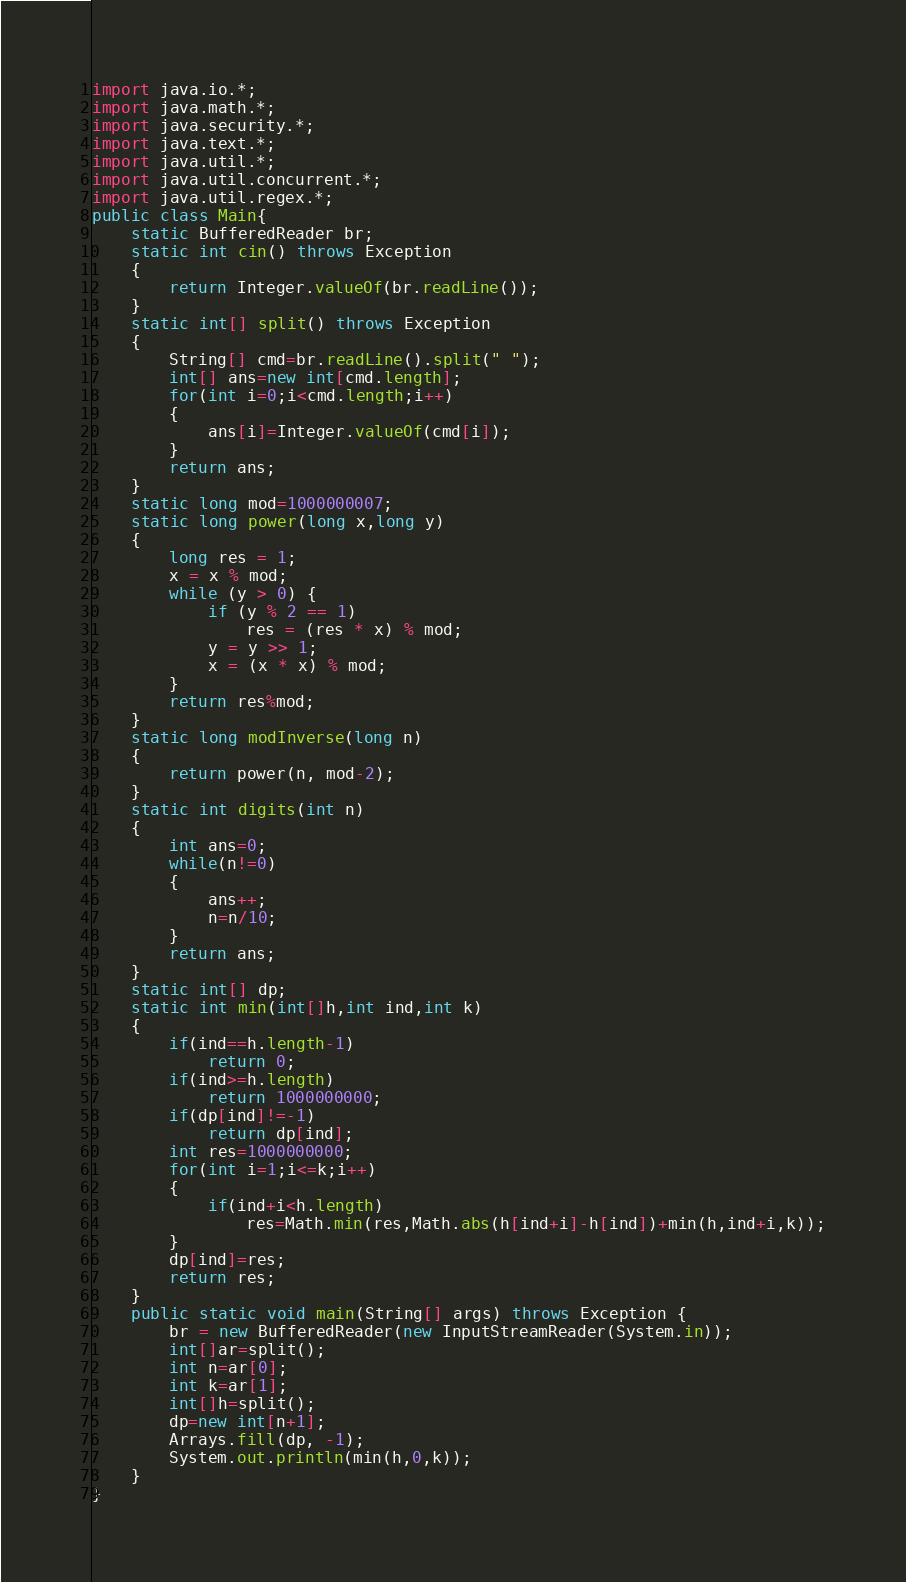Convert code to text. <code><loc_0><loc_0><loc_500><loc_500><_Java_>
import java.io.*;
import java.math.*;
import java.security.*;
import java.text.*;
import java.util.*;
import java.util.concurrent.*;
import java.util.regex.*;
public class Main{
	static BufferedReader br;
	static int cin() throws Exception
	{
		return Integer.valueOf(br.readLine());
	}
	static int[] split() throws Exception
	{
		String[] cmd=br.readLine().split(" ");
		int[] ans=new int[cmd.length];
		for(int i=0;i<cmd.length;i++)
		{
			ans[i]=Integer.valueOf(cmd[i]);
		}                                              
		return ans;
	} 
	static long mod=1000000007;
	static long power(long x,long y) 
    { 
        long res = 1; 
        x = x % mod; 
        while (y > 0) { 
            if (y % 2 == 1) 
                res = (res * x) % mod; 
            y = y >> 1;
            x = (x * x) % mod; 
        } 
        return res%mod; 
    } 
    static long modInverse(long n) 
    { 
        return power(n, mod-2); 
    } 
    static int digits(int n)
    {
    	int ans=0;
    	while(n!=0)
    	{
    		ans++;
    		n=n/10;
    	}
    	return ans;
    }
    static int[] dp;
    static int min(int[]h,int ind,int k)
    {
    	if(ind==h.length-1)
    		return 0;
    	if(ind>=h.length)
    		return 1000000000;
    	if(dp[ind]!=-1)
    		return dp[ind];
    	int res=1000000000;
    	for(int i=1;i<=k;i++)
    	{
    		if(ind+i<h.length)
    			res=Math.min(res,Math.abs(h[ind+i]-h[ind])+min(h,ind+i,k));
    	}
    	dp[ind]=res;
    	return res;
    }
    public static void main(String[] args) throws Exception {
        br = new BufferedReader(new InputStreamReader(System.in));
        int[]ar=split();
        int n=ar[0];
        int k=ar[1];
        int[]h=split();
        dp=new int[n+1];
        Arrays.fill(dp, -1);
        System.out.println(min(h,0,k));
    }
}</code> 